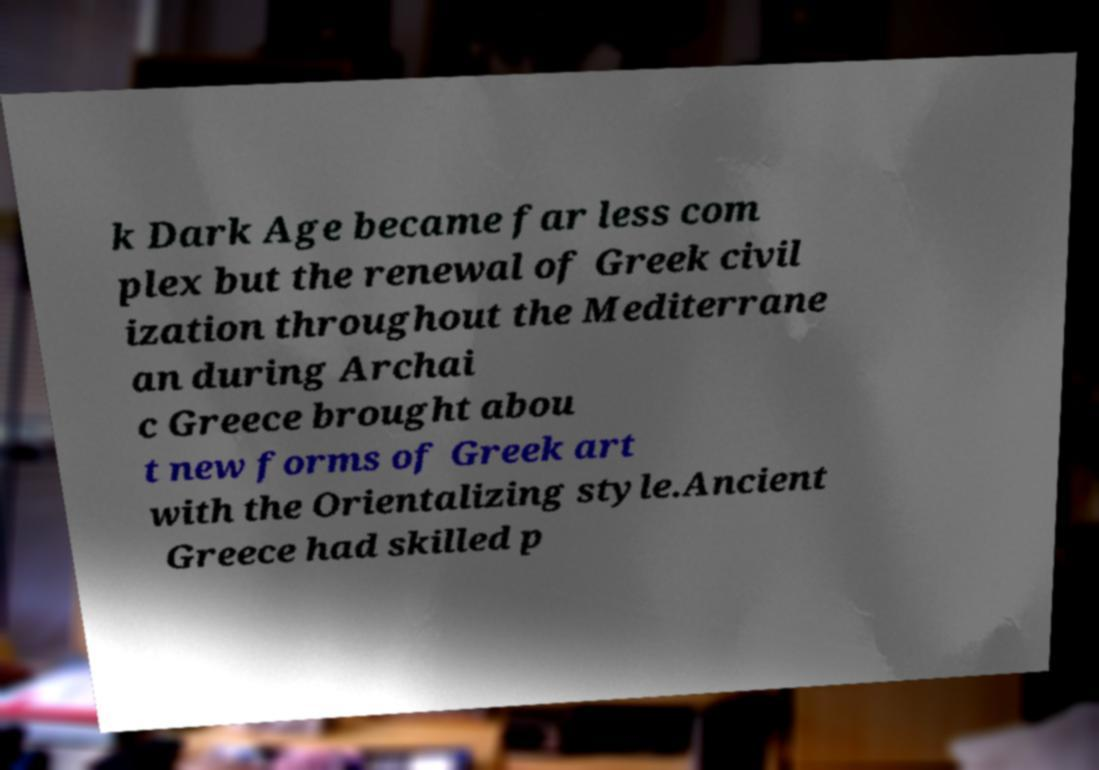I need the written content from this picture converted into text. Can you do that? k Dark Age became far less com plex but the renewal of Greek civil ization throughout the Mediterrane an during Archai c Greece brought abou t new forms of Greek art with the Orientalizing style.Ancient Greece had skilled p 